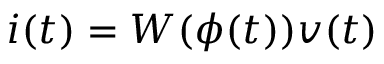<formula> <loc_0><loc_0><loc_500><loc_500>i ( t ) = W ( \phi ( t ) ) v ( t )</formula> 